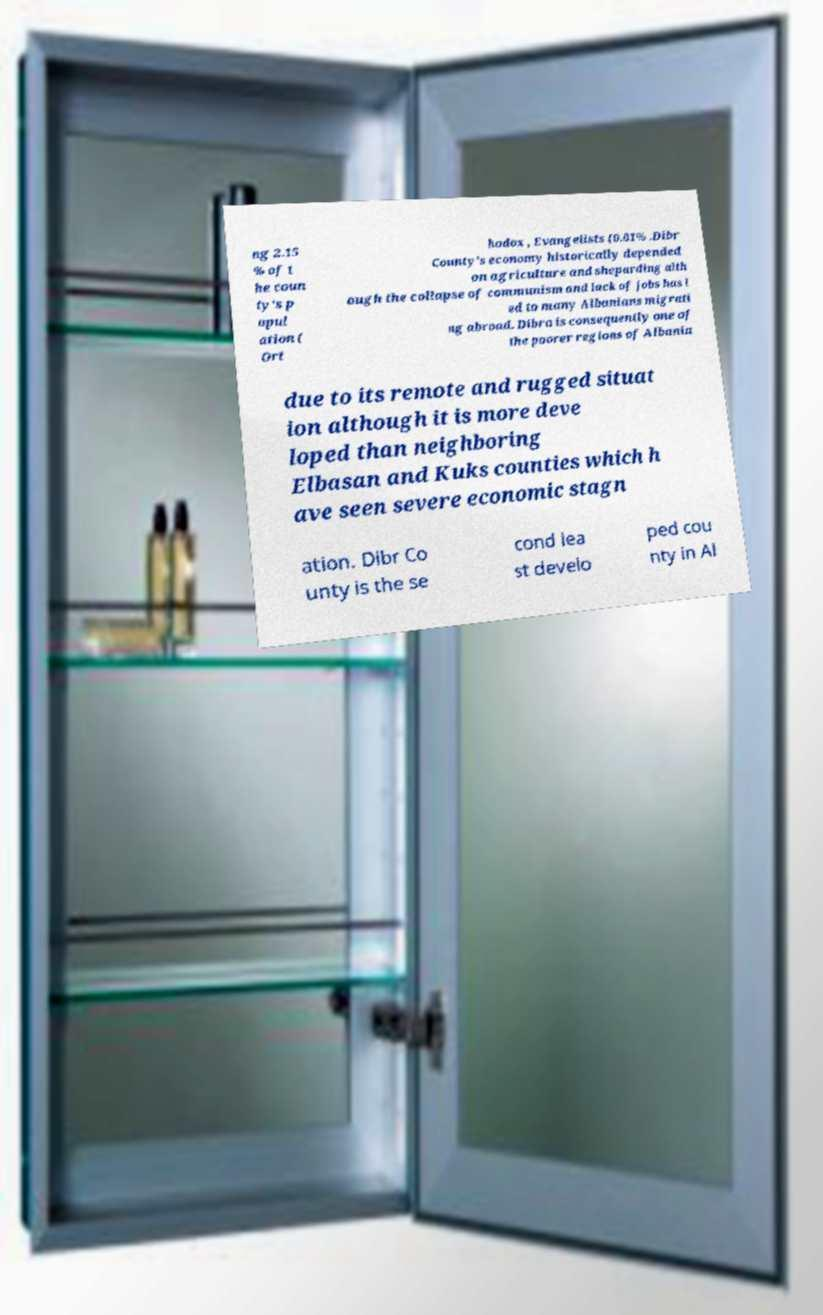There's text embedded in this image that I need extracted. Can you transcribe it verbatim? ng 2.15 % of t he coun ty's p opul ation ( Ort hodox , Evangelists (0.01% .Dibr County’s economy historically depended on agriculture and sheparding alth ough the collapse of communism and lack of jobs has l ed to many Albanians migrati ng abroad. Dibra is consequently one of the poorer regions of Albania due to its remote and rugged situat ion although it is more deve loped than neighboring Elbasan and Kuks counties which h ave seen severe economic stagn ation. Dibr Co unty is the se cond lea st develo ped cou nty in Al 